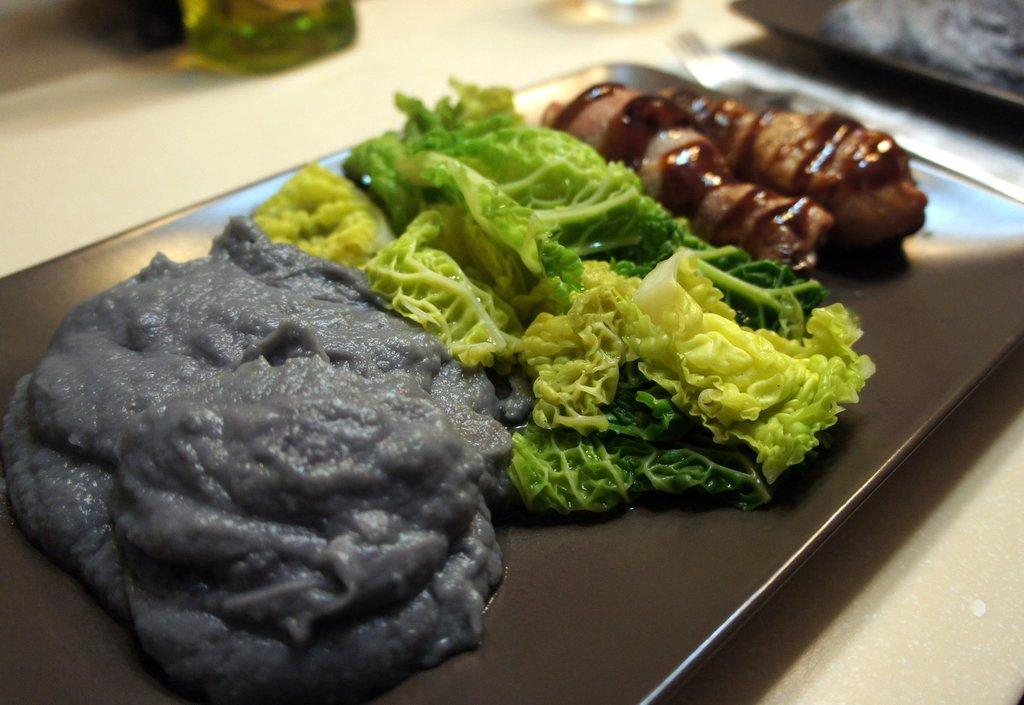What is the primary object on which the food items are placed in the image? There are food items on a black color tray in the image. Can you describe any other objects visible in the background of the image? Unfortunately, the provided facts do not give any information about objects in the background. How much profit does the stick in the image generate? There is no stick present in the image, so it is not possible to determine any profit generated by it. 